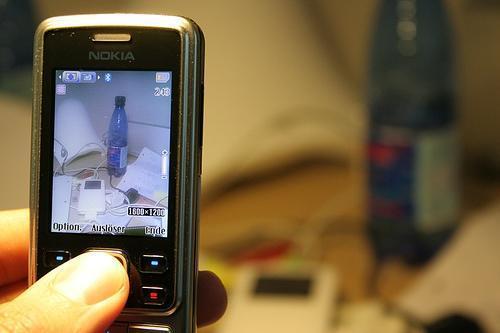How many bottles in the screen?
Give a very brief answer. 1. How many bars are left on the battery indicator?
Give a very brief answer. 1. How many people are there?
Give a very brief answer. 1. How many cell phones are there?
Give a very brief answer. 1. How many cats are there?
Give a very brief answer. 0. 